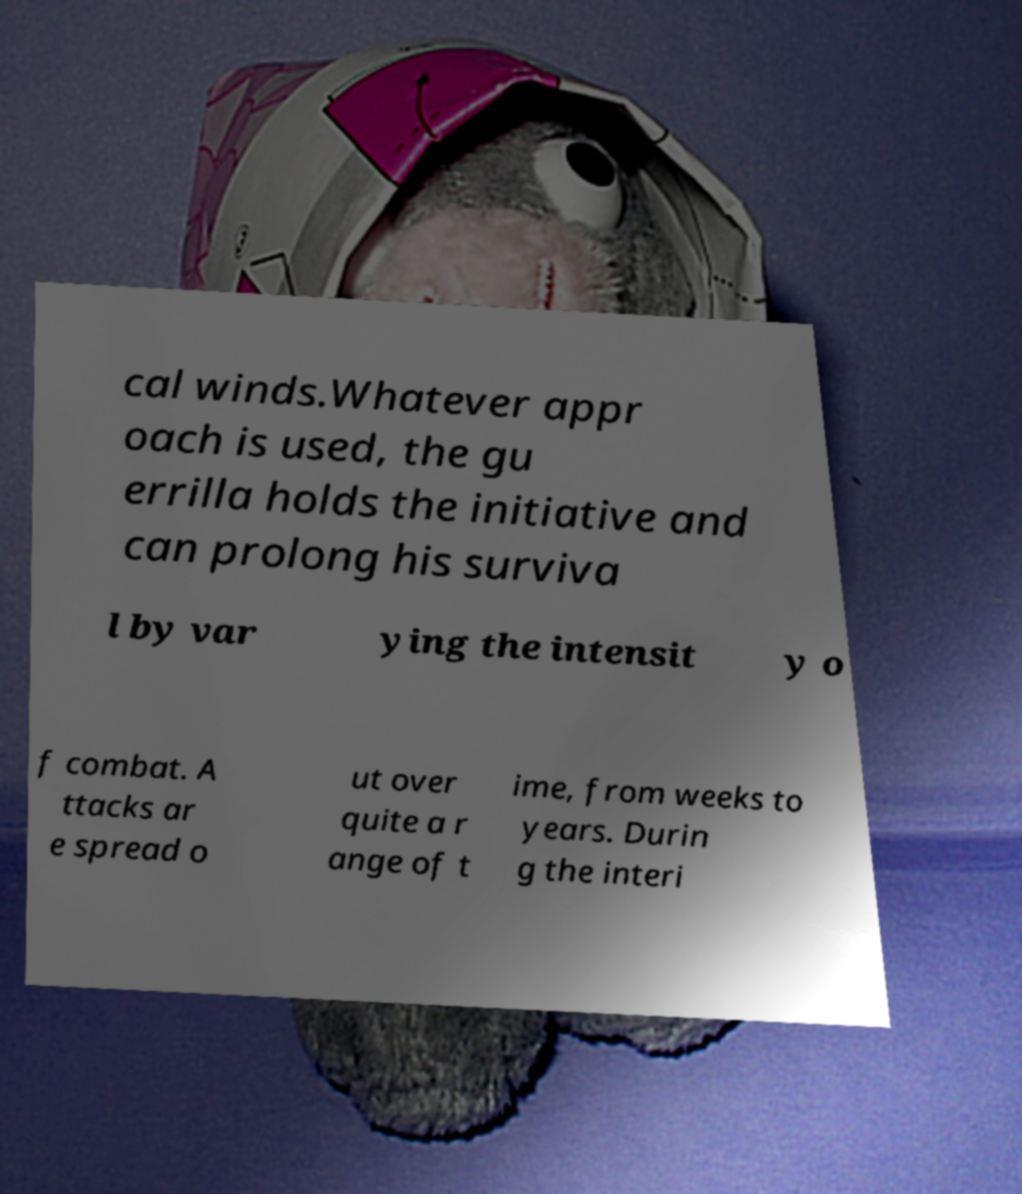I need the written content from this picture converted into text. Can you do that? cal winds.Whatever appr oach is used, the gu errilla holds the initiative and can prolong his surviva l by var ying the intensit y o f combat. A ttacks ar e spread o ut over quite a r ange of t ime, from weeks to years. Durin g the interi 